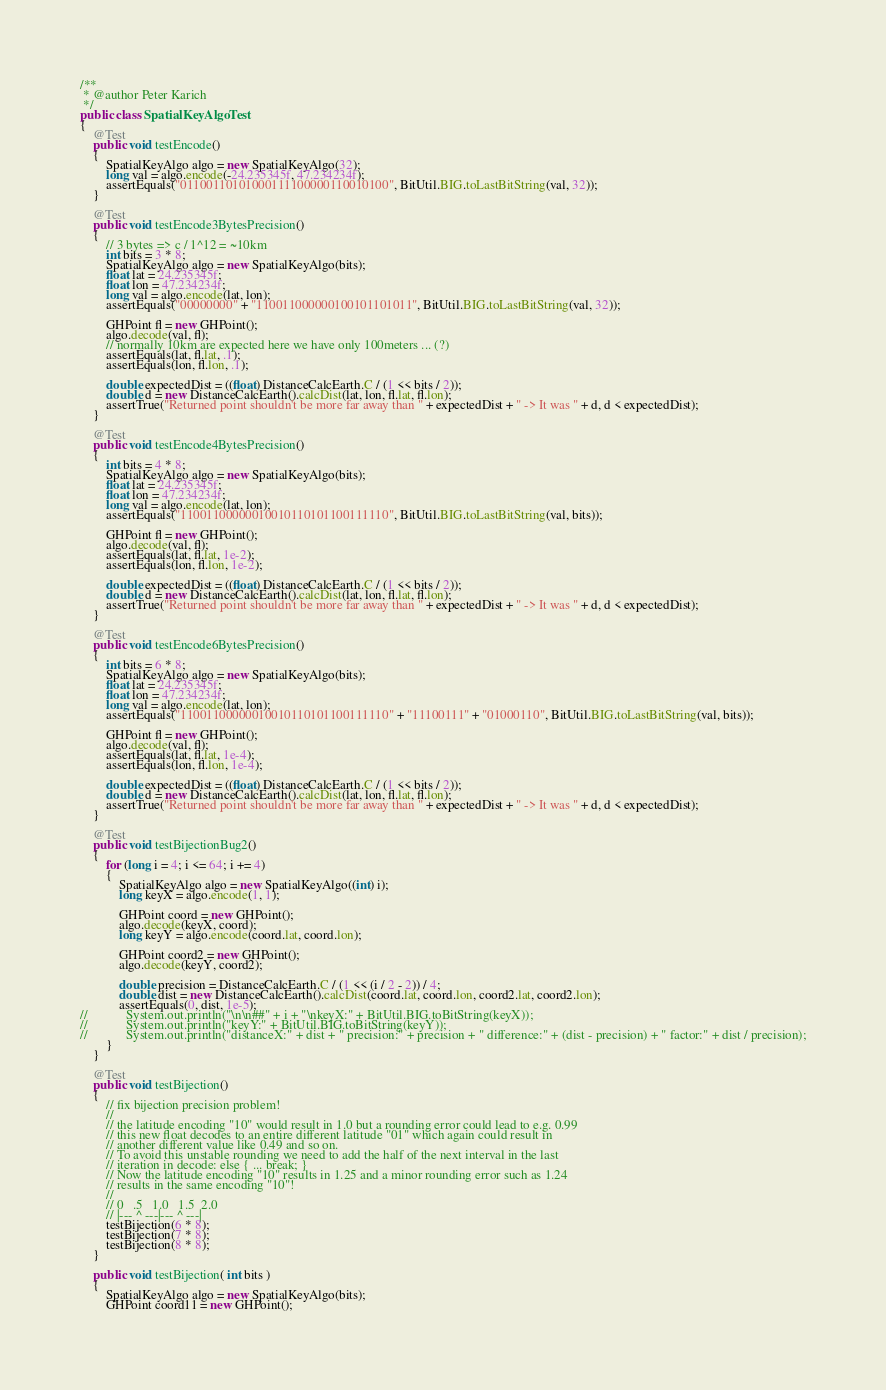<code> <loc_0><loc_0><loc_500><loc_500><_Java_>
/**
 * @author Peter Karich
 */
public class SpatialKeyAlgoTest
{
    @Test
    public void testEncode()
    {
        SpatialKeyAlgo algo = new SpatialKeyAlgo(32);
        long val = algo.encode(-24.235345f, 47.234234f);
        assertEquals("01100110101000111100000110010100", BitUtil.BIG.toLastBitString(val, 32));
    }

    @Test
    public void testEncode3BytesPrecision()
    {
        // 3 bytes => c / 1^12 = ~10km
        int bits = 3 * 8;
        SpatialKeyAlgo algo = new SpatialKeyAlgo(bits);
        float lat = 24.235345f;
        float lon = 47.234234f;
        long val = algo.encode(lat, lon);
        assertEquals("00000000" + "110011000000100101101011", BitUtil.BIG.toLastBitString(val, 32));

        GHPoint fl = new GHPoint();
        algo.decode(val, fl);
        // normally 10km are expected here we have only 100meters ... (?)
        assertEquals(lat, fl.lat, .1);
        assertEquals(lon, fl.lon, .1);

        double expectedDist = ((float) DistanceCalcEarth.C / (1 << bits / 2));
        double d = new DistanceCalcEarth().calcDist(lat, lon, fl.lat, fl.lon);
        assertTrue("Returned point shouldn't be more far away than " + expectedDist + " -> It was " + d, d < expectedDist);
    }

    @Test
    public void testEncode4BytesPrecision()
    {
        int bits = 4 * 8;
        SpatialKeyAlgo algo = new SpatialKeyAlgo(bits);
        float lat = 24.235345f;
        float lon = 47.234234f;
        long val = algo.encode(lat, lon);
        assertEquals("11001100000010010110101100111110", BitUtil.BIG.toLastBitString(val, bits));

        GHPoint fl = new GHPoint();
        algo.decode(val, fl);
        assertEquals(lat, fl.lat, 1e-2);
        assertEquals(lon, fl.lon, 1e-2);

        double expectedDist = ((float) DistanceCalcEarth.C / (1 << bits / 2));
        double d = new DistanceCalcEarth().calcDist(lat, lon, fl.lat, fl.lon);
        assertTrue("Returned point shouldn't be more far away than " + expectedDist + " -> It was " + d, d < expectedDist);
    }

    @Test
    public void testEncode6BytesPrecision()
    {
        int bits = 6 * 8;
        SpatialKeyAlgo algo = new SpatialKeyAlgo(bits);
        float lat = 24.235345f;
        float lon = 47.234234f;
        long val = algo.encode(lat, lon);
        assertEquals("11001100000010010110101100111110" + "11100111" + "01000110", BitUtil.BIG.toLastBitString(val, bits));

        GHPoint fl = new GHPoint();
        algo.decode(val, fl);
        assertEquals(lat, fl.lat, 1e-4);
        assertEquals(lon, fl.lon, 1e-4);

        double expectedDist = ((float) DistanceCalcEarth.C / (1 << bits / 2));
        double d = new DistanceCalcEarth().calcDist(lat, lon, fl.lat, fl.lon);
        assertTrue("Returned point shouldn't be more far away than " + expectedDist + " -> It was " + d, d < expectedDist);
    }

    @Test
    public void testBijectionBug2()
    {
        for (long i = 4; i <= 64; i += 4)
        {
            SpatialKeyAlgo algo = new SpatialKeyAlgo((int) i);
            long keyX = algo.encode(1, 1);

            GHPoint coord = new GHPoint();
            algo.decode(keyX, coord);
            long keyY = algo.encode(coord.lat, coord.lon);

            GHPoint coord2 = new GHPoint();
            algo.decode(keyY, coord2);

            double precision = DistanceCalcEarth.C / (1 << (i / 2 - 2)) / 4;
            double dist = new DistanceCalcEarth().calcDist(coord.lat, coord.lon, coord2.lat, coord2.lon);
            assertEquals(0, dist, 1e-5);
//            System.out.println("\n\n##" + i + "\nkeyX:" + BitUtil.BIG.toBitString(keyX));
//            System.out.println("keyY:" + BitUtil.BIG.toBitString(keyY));
//            System.out.println("distanceX:" + dist + " precision:" + precision + " difference:" + (dist - precision) + " factor:" + dist / precision);
        }
    }

    @Test
    public void testBijection()
    {
        // fix bijection precision problem!
        //
        // the latitude encoding "10" would result in 1.0 but a rounding error could lead to e.g. 0.99
        // this new float decodes to an entire different latitude "01" which again could result in 
        // another different value like 0.49 and so on. 
        // To avoid this unstable rounding we need to add the half of the next interval in the last 
        // iteration in decode: else { ... break; }
        // Now the latitude encoding "10" results in 1.25 and a minor rounding error such as 1.24 
        // results in the same encoding "10"!
        //
        // 0   .5   1.0   1.5  2.0
        // |--- ^ ---|--- ^ ---|        
        testBijection(6 * 8);
        testBijection(7 * 8);
        testBijection(8 * 8);
    }

    public void testBijection( int bits )
    {
        SpatialKeyAlgo algo = new SpatialKeyAlgo(bits);
        GHPoint coord11 = new GHPoint();</code> 